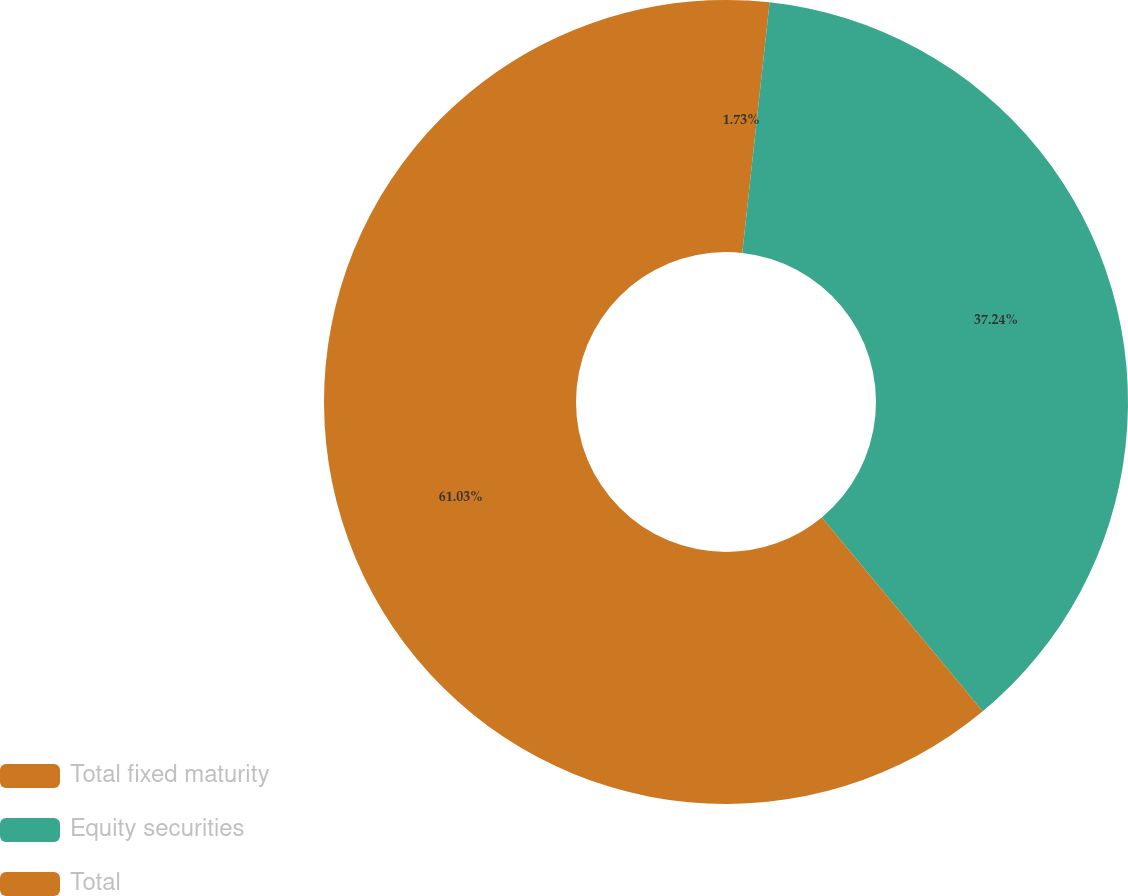Convert chart. <chart><loc_0><loc_0><loc_500><loc_500><pie_chart><fcel>Total fixed maturity<fcel>Equity securities<fcel>Total<nl><fcel>1.73%<fcel>37.24%<fcel>61.02%<nl></chart> 